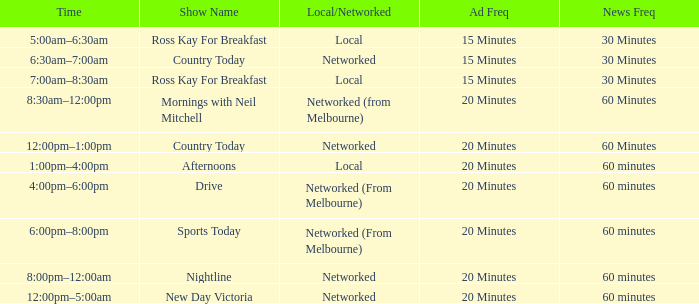What Time has a Show Name of mornings with neil mitchell? 8:30am–12:00pm. 